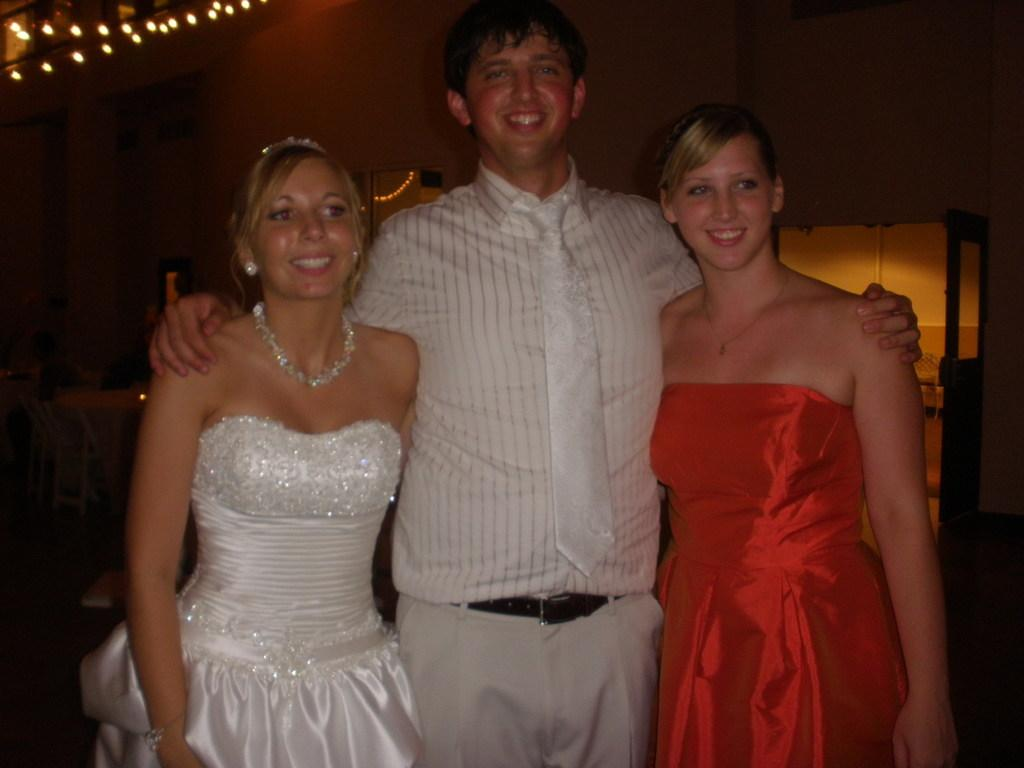How many people are in the image? There are two people in the image, a man and a woman. What are the man and woman doing in the image? Both the man and woman are standing and smiling. What can be seen in the background of the image? There is a wall in the background of the image. What is visible at the left top of the image? There are lights visible at the left top of the image. What type of cushion is the woman sitting on in the image? There is no cushion present in the image, as both the man and woman are standing. What type of dinner is being served in the image? There is no dinner present in the image; it only shows the man and woman standing and smiling. 